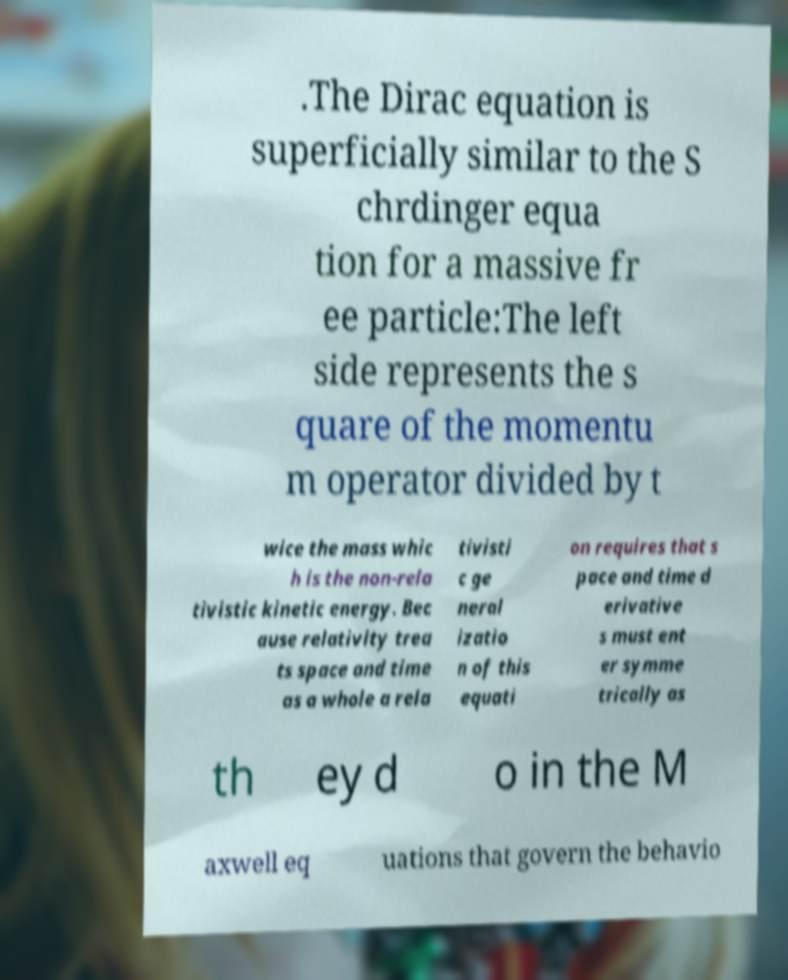I need the written content from this picture converted into text. Can you do that? .The Dirac equation is superficially similar to the S chrdinger equa tion for a massive fr ee particle:The left side represents the s quare of the momentu m operator divided by t wice the mass whic h is the non-rela tivistic kinetic energy. Bec ause relativity trea ts space and time as a whole a rela tivisti c ge neral izatio n of this equati on requires that s pace and time d erivative s must ent er symme trically as th ey d o in the M axwell eq uations that govern the behavio 